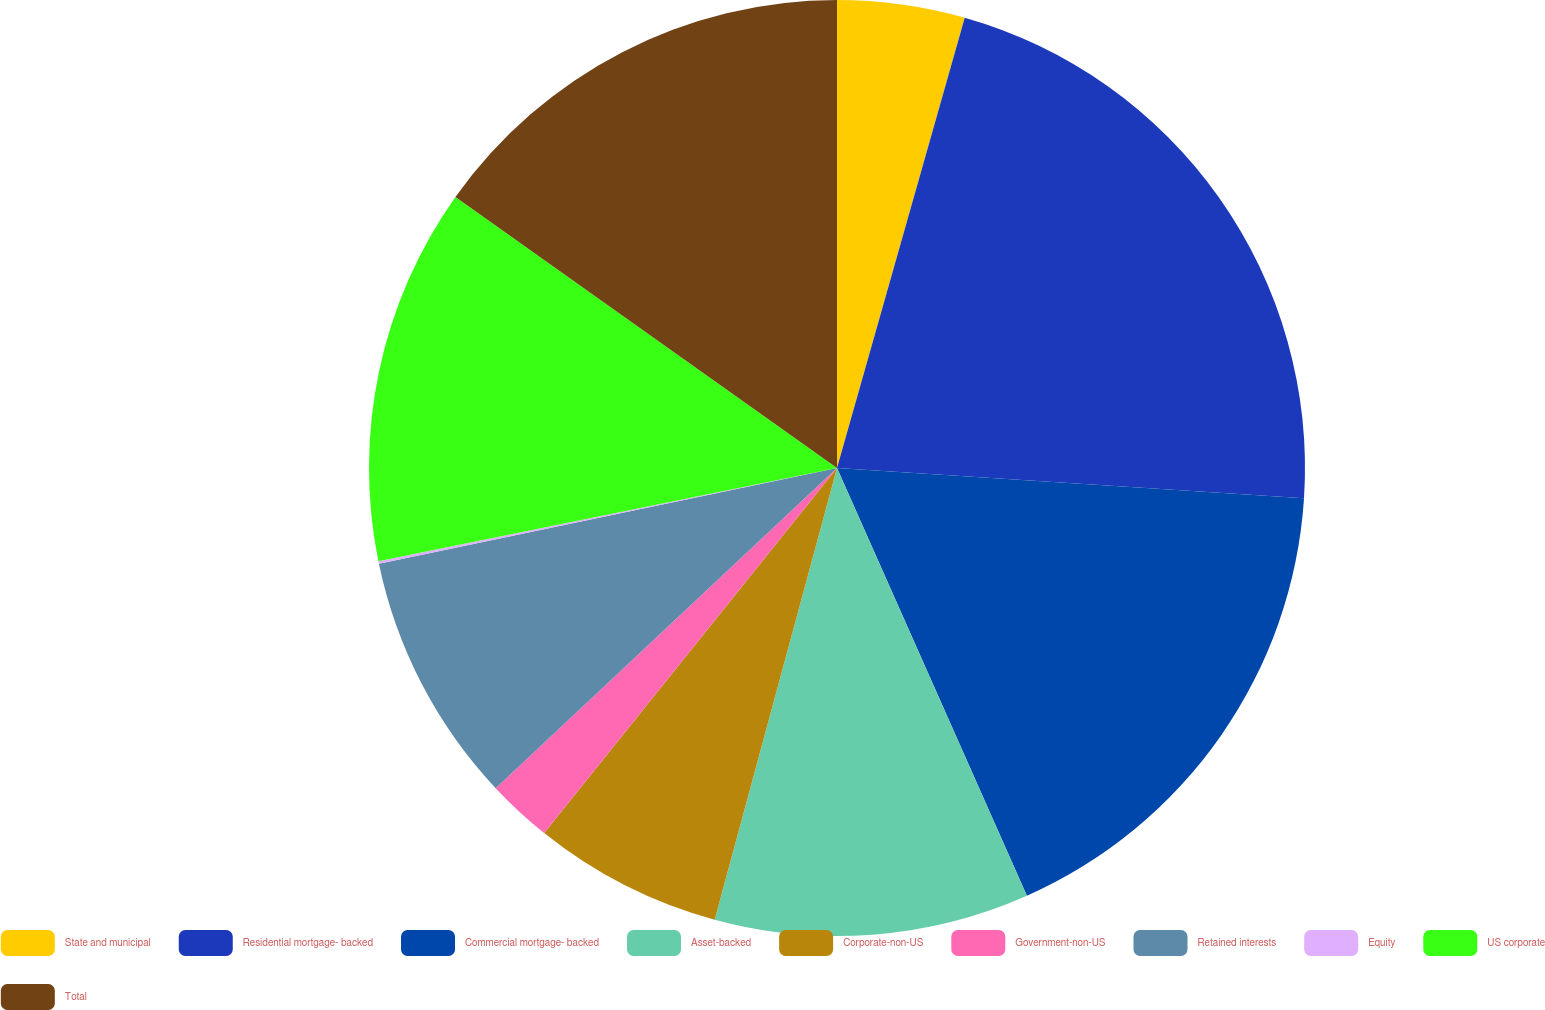Convert chart to OTSL. <chart><loc_0><loc_0><loc_500><loc_500><pie_chart><fcel>State and municipal<fcel>Residential mortgage- backed<fcel>Commercial mortgage- backed<fcel>Asset-backed<fcel>Corporate-non-US<fcel>Government-non-US<fcel>Retained interests<fcel>Equity<fcel>US corporate<fcel>Total<nl><fcel>4.4%<fcel>21.63%<fcel>17.32%<fcel>10.86%<fcel>6.55%<fcel>2.25%<fcel>8.71%<fcel>0.09%<fcel>13.02%<fcel>15.17%<nl></chart> 